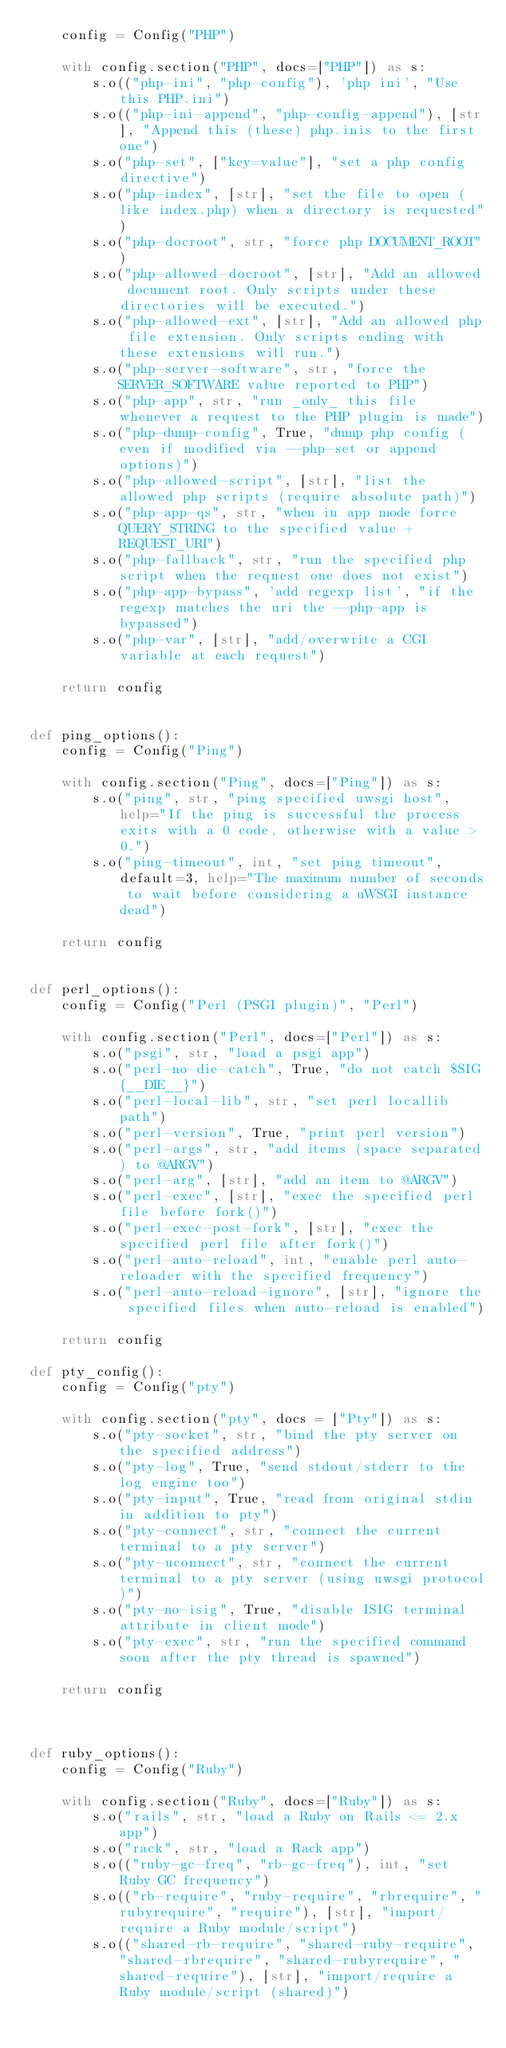<code> <loc_0><loc_0><loc_500><loc_500><_Python_>    config = Config("PHP")

    with config.section("PHP", docs=["PHP"]) as s:
        s.o(("php-ini", "php-config"), 'php ini', "Use this PHP.ini")
        s.o(("php-ini-append", "php-config-append"), [str], "Append this (these) php.inis to the first one")
        s.o("php-set", ["key=value"], "set a php config directive")
        s.o("php-index", [str], "set the file to open (like index.php) when a directory is requested")
        s.o("php-docroot", str, "force php DOCUMENT_ROOT")
        s.o("php-allowed-docroot", [str], "Add an allowed document root. Only scripts under these directories will be executed.")
        s.o("php-allowed-ext", [str], "Add an allowed php file extension. Only scripts ending with these extensions will run.")
        s.o("php-server-software", str, "force the SERVER_SOFTWARE value reported to PHP")
        s.o("php-app", str, "run _only_ this file whenever a request to the PHP plugin is made")
        s.o("php-dump-config", True, "dump php config (even if modified via --php-set or append options)")
        s.o("php-allowed-script", [str], "list the allowed php scripts (require absolute path)")
        s.o("php-app-qs", str, "when in app mode force QUERY_STRING to the specified value + REQUEST_URI")
        s.o("php-fallback", str, "run the specified php script when the request one does not exist")
        s.o("php-app-bypass", 'add regexp list', "if the regexp matches the uri the --php-app is bypassed")
        s.o("php-var", [str], "add/overwrite a CGI variable at each request")

    return config


def ping_options():
    config = Config("Ping")

    with config.section("Ping", docs=["Ping"]) as s:
        s.o("ping", str, "ping specified uwsgi host", help="If the ping is successful the process exits with a 0 code, otherwise with a value > 0.")
        s.o("ping-timeout", int, "set ping timeout", default=3, help="The maximum number of seconds to wait before considering a uWSGI instance dead")

    return config


def perl_options():
    config = Config("Perl (PSGI plugin)", "Perl")

    with config.section("Perl", docs=["Perl"]) as s:
        s.o("psgi", str, "load a psgi app")
        s.o("perl-no-die-catch", True, "do not catch $SIG{__DIE__}")
        s.o("perl-local-lib", str, "set perl locallib path")
        s.o("perl-version", True, "print perl version")
        s.o("perl-args", str, "add items (space separated) to @ARGV")
        s.o("perl-arg", [str], "add an item to @ARGV")
        s.o("perl-exec", [str], "exec the specified perl file before fork()")
        s.o("perl-exec-post-fork", [str], "exec the specified perl file after fork()")
        s.o("perl-auto-reload", int, "enable perl auto-reloader with the specified frequency")
        s.o("perl-auto-reload-ignore", [str], "ignore the specified files when auto-reload is enabled")

    return config

def pty_config():
    config = Config("pty")
    
    with config.section("pty", docs = ["Pty"]) as s:
        s.o("pty-socket", str, "bind the pty server on the specified address")
        s.o("pty-log", True, "send stdout/stderr to the log engine too")
        s.o("pty-input", True, "read from original stdin in addition to pty")
        s.o("pty-connect", str, "connect the current terminal to a pty server")
        s.o("pty-uconnect", str, "connect the current terminal to a pty server (using uwsgi protocol)")
        s.o("pty-no-isig", True, "disable ISIG terminal attribute in client mode")
        s.o("pty-exec", str, "run the specified command soon after the pty thread is spawned")
    
    return config



def ruby_options():
    config = Config("Ruby")

    with config.section("Ruby", docs=["Ruby"]) as s:
        s.o("rails", str, "load a Ruby on Rails <= 2.x app")
        s.o("rack", str, "load a Rack app")
        s.o(("ruby-gc-freq", "rb-gc-freq"), int, "set Ruby GC frequency")
        s.o(("rb-require", "ruby-require", "rbrequire", "rubyrequire", "require"), [str], "import/require a Ruby module/script")
        s.o(("shared-rb-require", "shared-ruby-require", "shared-rbrequire", "shared-rubyrequire", "shared-require"), [str], "import/require a Ruby module/script (shared)")</code> 